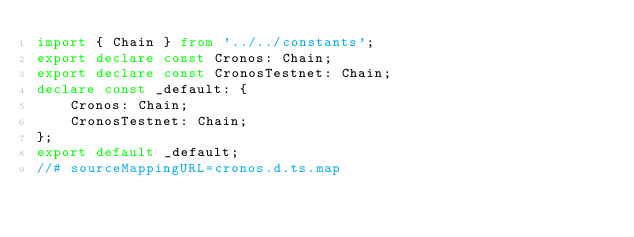<code> <loc_0><loc_0><loc_500><loc_500><_TypeScript_>import { Chain } from '../../constants';
export declare const Cronos: Chain;
export declare const CronosTestnet: Chain;
declare const _default: {
    Cronos: Chain;
    CronosTestnet: Chain;
};
export default _default;
//# sourceMappingURL=cronos.d.ts.map</code> 